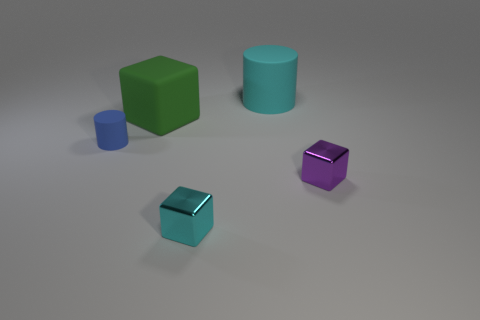Subtract all shiny cubes. How many cubes are left? 1 Add 3 purple cubes. How many objects exist? 8 Subtract all purple blocks. How many blocks are left? 2 Subtract 0 yellow cubes. How many objects are left? 5 Subtract all cubes. How many objects are left? 2 Subtract 2 cylinders. How many cylinders are left? 0 Subtract all blue cylinders. Subtract all yellow blocks. How many cylinders are left? 1 Subtract all yellow balls. How many cyan cylinders are left? 1 Subtract all gray metallic cylinders. Subtract all tiny purple cubes. How many objects are left? 4 Add 4 blocks. How many blocks are left? 7 